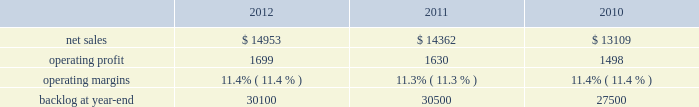Aeronautics business segment 2019s results of operations discussion .
The increase in our consolidated net adjustments for 2011 as compared to 2010 primarily was due to an increase in profit booking rate adjustments at our is&gs and aeronautics business segments .
Aeronautics our aeronautics business segment is engaged in the research , design , development , manufacture , integration , sustainment , support , and upgrade of advanced military aircraft , including combat and air mobility aircraft , unmanned air vehicles , and related technologies .
Aeronautics 2019 major programs include the f-35 lightning ii joint strike fighter , f-22 raptor , f-16 fighting falcon , c-130 hercules , and the c-5m super galaxy .
Aeronautics 2019 operating results included the following ( in millions ) : .
2012 compared to 2011 aeronautics 2019 net sales for 2012 increased $ 591 million , or 4% ( 4 % ) , compared to 2011 .
The increase was attributable to higher net sales of approximately $ 745 million from f-35 lrip contracts principally due to increased production volume ; about $ 285 million from f-16 programs primarily due to higher aircraft deliveries ( 37 f-16 aircraft delivered in 2012 compared to 22 in 2011 ) partially offset by lower volume on sustainment activities due to the completion of modification programs for certain international customers ; and approximately $ 140 million from c-5 programs due to higher aircraft deliveries ( four c-5m aircraft delivered in 2012 compared to two in 2011 ) .
Partially offsetting the increases were lower net sales of approximately $ 365 million from decreased production volume and lower risk retirements on the f-22 program as final aircraft deliveries were completed in the second quarter of 2012 ; approximately $ 110 million from the f-35 development contract primarily due to the inception-to-date effect of reducing the profit booking rate in the second quarter of 2012 and to a lesser extent lower volume ; and about $ 95 million from a decrease in volume on other sustainment activities partially offset by various other aeronautics programs due to higher volume .
Net sales for c-130 programs were comparable to 2011 as a decline in sustainment activities largely was offset by increased aircraft deliveries .
Aeronautics 2019 operating profit for 2012 increased $ 69 million , or 4% ( 4 % ) , compared to 2011 .
The increase was attributable to higher operating profit of approximately $ 105 million from c-130 programs due to an increase in risk retirements ; about $ 50 million from f-16 programs due to higher aircraft deliveries partially offset by a decline in risk retirements ; approximately $ 50 million from f-35 lrip contracts due to increased production volume and risk retirements ; and about $ 50 million from the completion of purchased intangible asset amortization on certain f-16 contracts .
Partially offsetting the increases was lower operating profit of about $ 90 million from the f-35 development contract primarily due to the inception- to-date effect of reducing the profit booking rate in the second quarter of 2012 ; approximately $ 50 million from decreased production volume and risk retirements on the f-22 program partially offset by a resolution of a contractual matter in the second quarter of 2012 ; and approximately $ 45 million primarily due to a decrease in risk retirements on other sustainment activities partially offset by various other aeronautics programs due to increased risk retirements and volume .
Operating profit for c-5 programs was comparable to 2011 .
Adjustments not related to volume , including net profit booking rate adjustments and other matters described above , were approximately $ 30 million lower for 2012 compared to 2011 .
2011 compared to 2010 aeronautics 2019 net sales for 2011 increased $ 1.3 billion , or 10% ( 10 % ) , compared to 2010 .
The growth in net sales primarily was due to higher volume of about $ 850 million for work performed on the f-35 lrip contracts as production increased ; higher volume of about $ 745 million for c-130 programs due to an increase in deliveries ( 33 c-130j aircraft delivered in 2011 compared to 25 during 2010 ) and support activities ; about $ 425 million for f-16 support activities and an increase in aircraft deliveries ( 22 f-16 aircraft delivered in 2011 compared to 20 during 2010 ) ; and approximately $ 90 million for higher volume on c-5 programs ( two c-5m aircraft delivered in 2011 compared to one during 2010 ) .
These increases partially were offset by a decline in net sales of approximately $ 675 million due to lower volume on the f-22 program and lower net sales of about $ 155 million for the f-35 development contract as development work decreased. .
What is the growth rate in operating profit for aeronautics in 2011? 
Computations: ((1630 - 1498) / 1498)
Answer: 0.08812. 